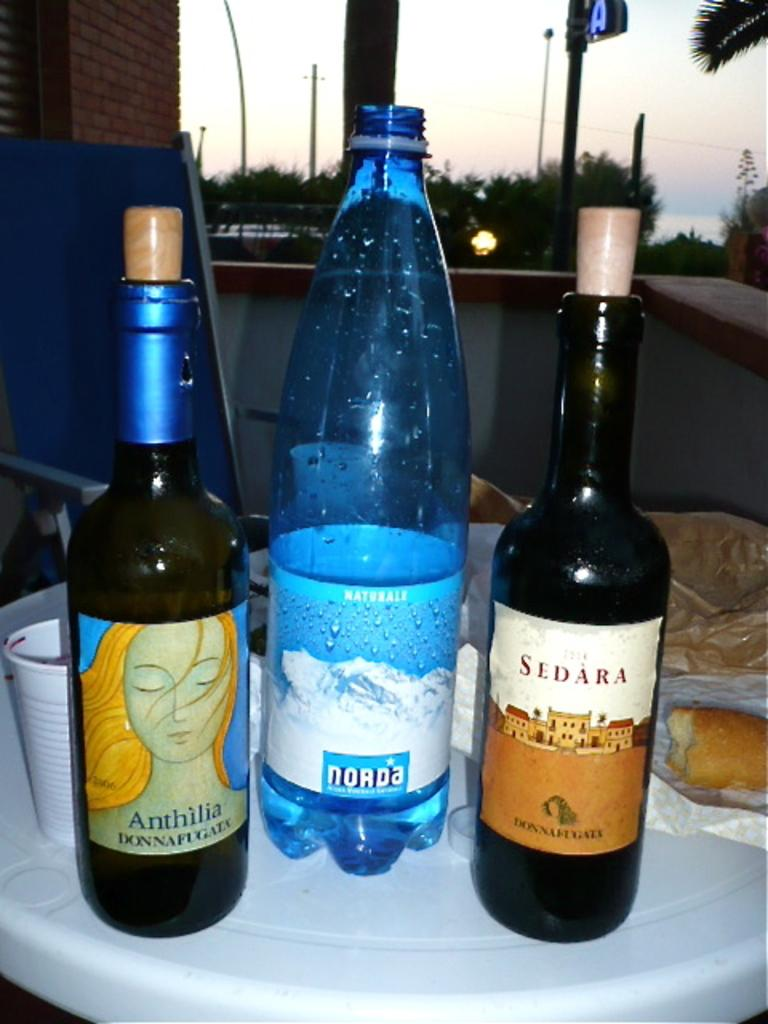<image>
Summarize the visual content of the image. Bottles of liquid with one that says Norda on the bottom. 